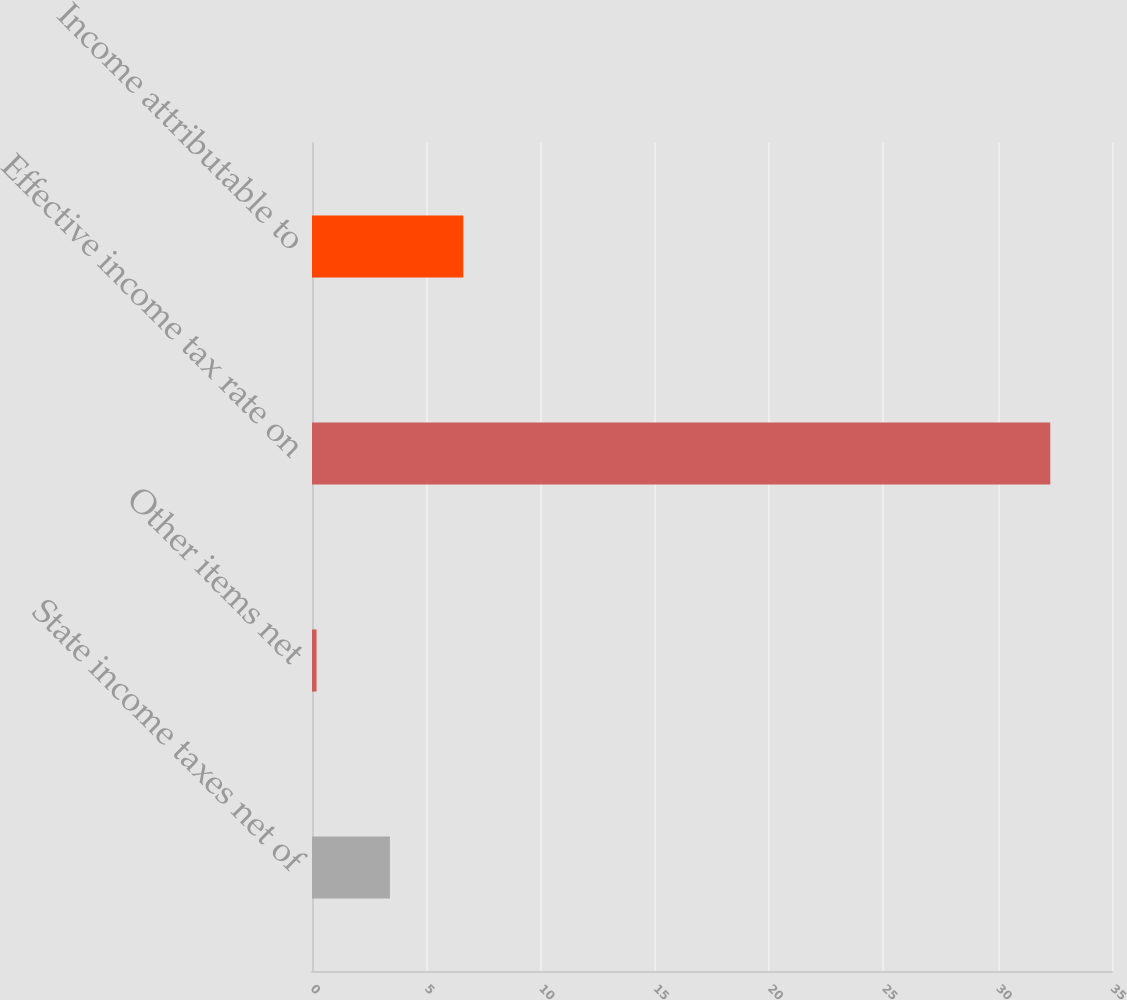Convert chart to OTSL. <chart><loc_0><loc_0><loc_500><loc_500><bar_chart><fcel>State income taxes net of<fcel>Other items net<fcel>Effective income tax rate on<fcel>Income attributable to<nl><fcel>3.41<fcel>0.2<fcel>32.3<fcel>6.62<nl></chart> 